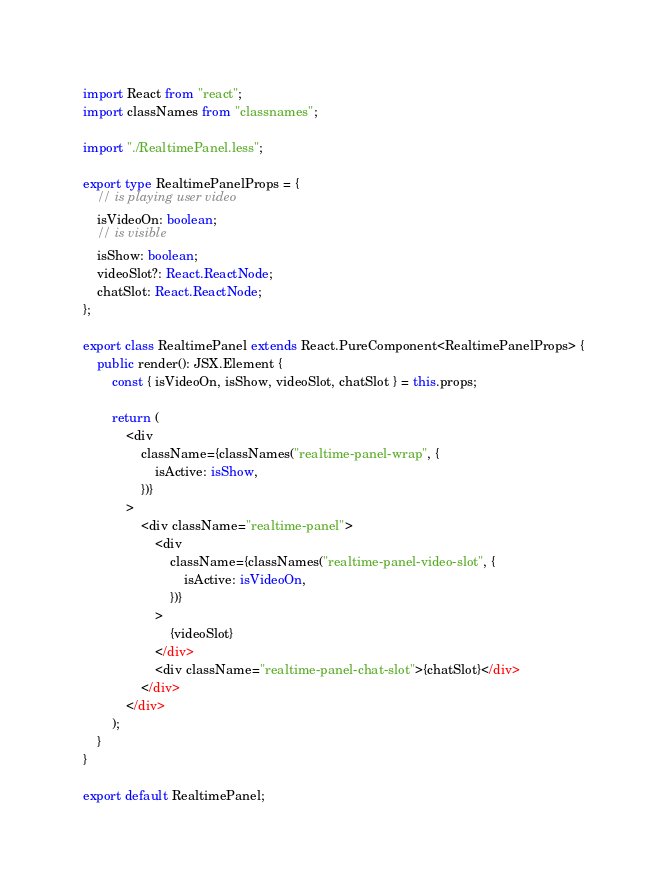Convert code to text. <code><loc_0><loc_0><loc_500><loc_500><_TypeScript_>import React from "react";
import classNames from "classnames";

import "./RealtimePanel.less";

export type RealtimePanelProps = {
    // is playing user video
    isVideoOn: boolean;
    // is visible
    isShow: boolean;
    videoSlot?: React.ReactNode;
    chatSlot: React.ReactNode;
};

export class RealtimePanel extends React.PureComponent<RealtimePanelProps> {
    public render(): JSX.Element {
        const { isVideoOn, isShow, videoSlot, chatSlot } = this.props;

        return (
            <div
                className={classNames("realtime-panel-wrap", {
                    isActive: isShow,
                })}
            >
                <div className="realtime-panel">
                    <div
                        className={classNames("realtime-panel-video-slot", {
                            isActive: isVideoOn,
                        })}
                    >
                        {videoSlot}
                    </div>
                    <div className="realtime-panel-chat-slot">{chatSlot}</div>
                </div>
            </div>
        );
    }
}

export default RealtimePanel;
</code> 